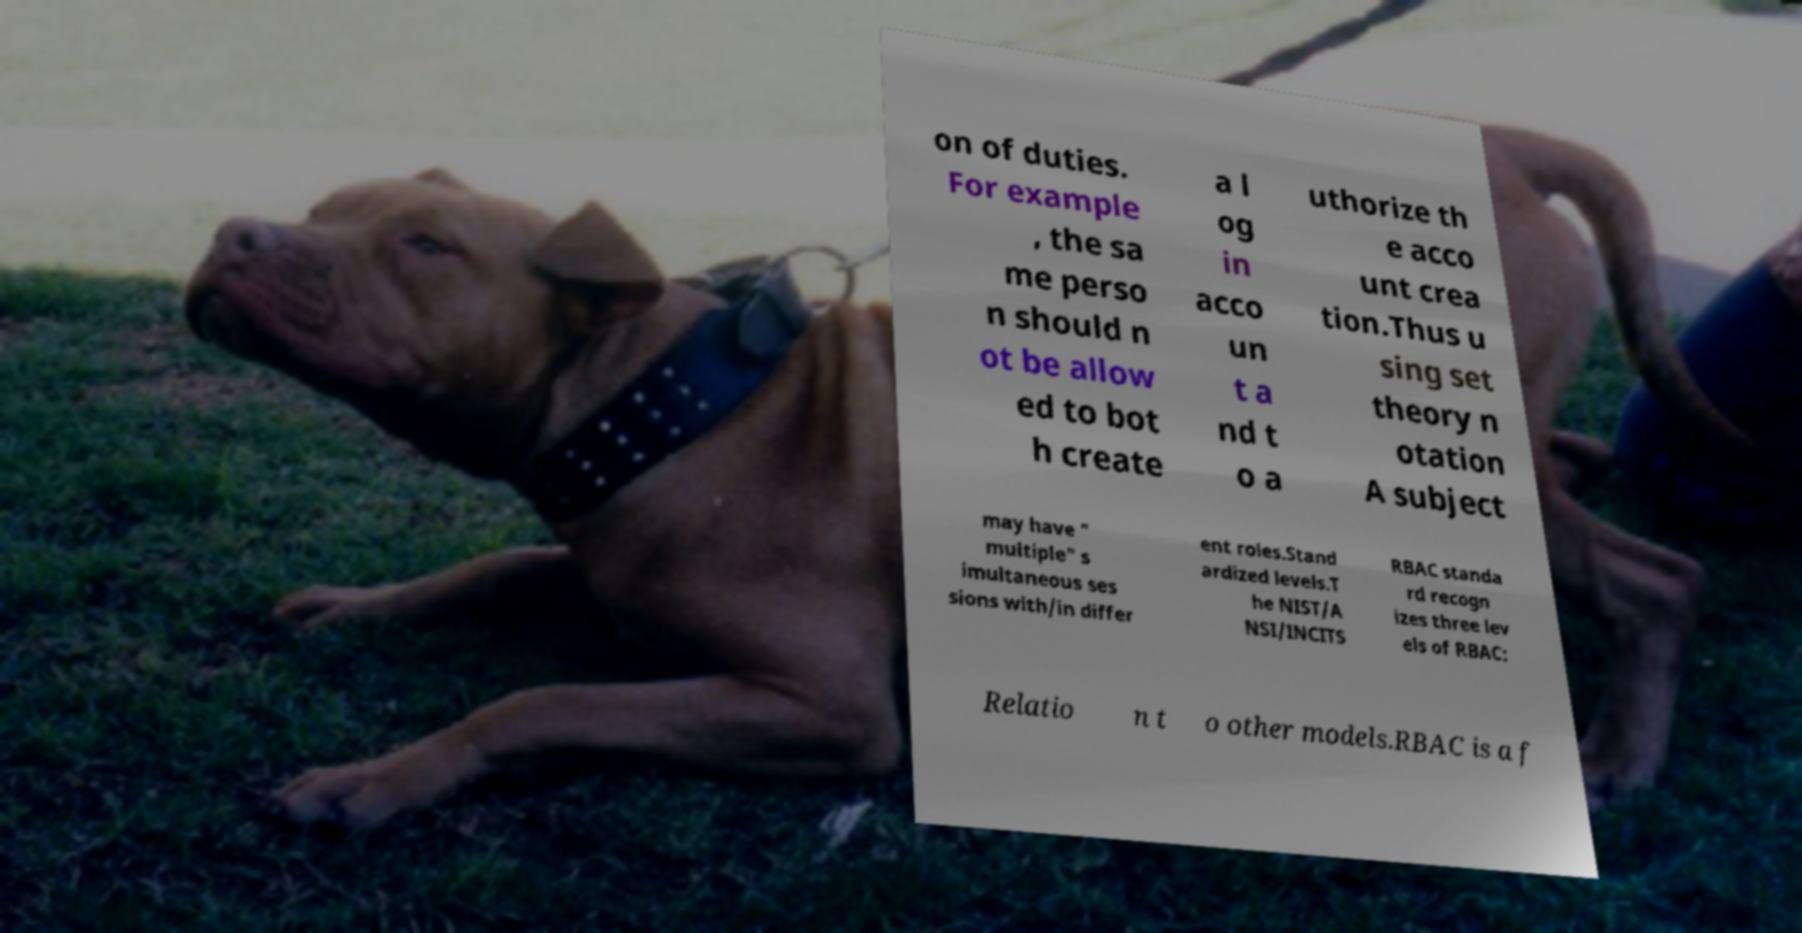For documentation purposes, I need the text within this image transcribed. Could you provide that? on of duties. For example , the sa me perso n should n ot be allow ed to bot h create a l og in acco un t a nd t o a uthorize th e acco unt crea tion.Thus u sing set theory n otation A subject may have " multiple" s imultaneous ses sions with/in differ ent roles.Stand ardized levels.T he NIST/A NSI/INCITS RBAC standa rd recogn izes three lev els of RBAC: Relatio n t o other models.RBAC is a f 